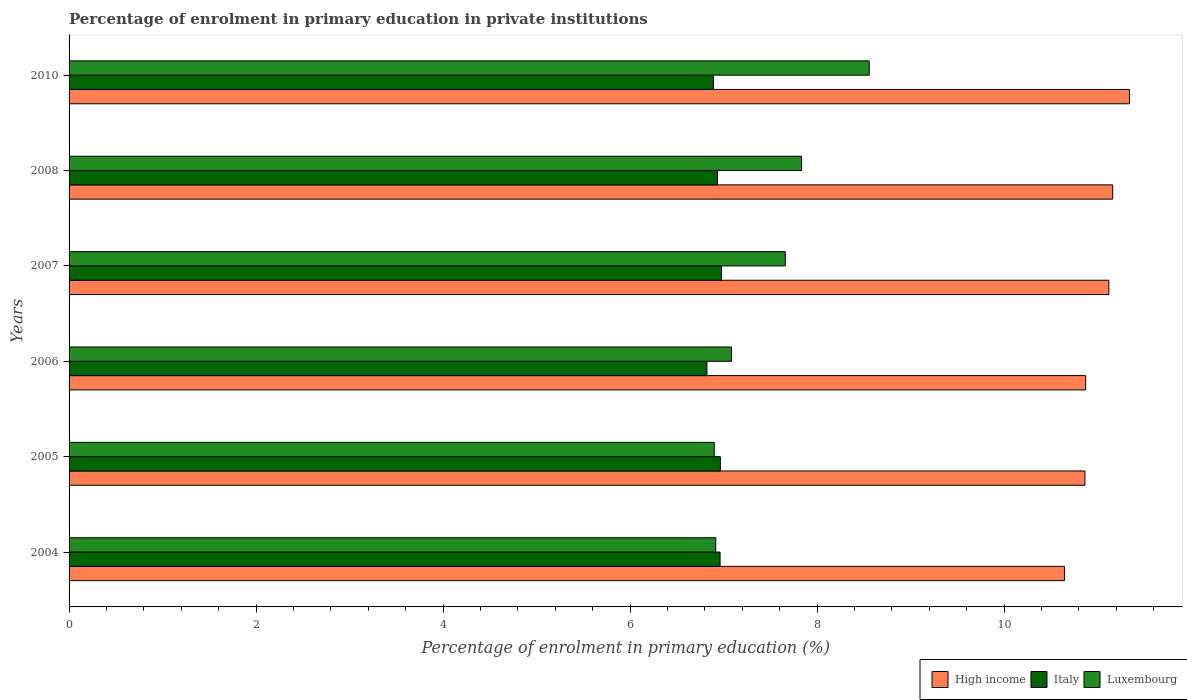Are the number of bars on each tick of the Y-axis equal?
Your answer should be very brief. Yes. How many bars are there on the 5th tick from the top?
Make the answer very short. 3. What is the percentage of enrolment in primary education in Italy in 2005?
Your answer should be compact. 6.97. Across all years, what is the maximum percentage of enrolment in primary education in High income?
Give a very brief answer. 11.34. Across all years, what is the minimum percentage of enrolment in primary education in High income?
Offer a very short reply. 10.64. What is the total percentage of enrolment in primary education in Italy in the graph?
Make the answer very short. 41.55. What is the difference between the percentage of enrolment in primary education in High income in 2005 and that in 2007?
Offer a very short reply. -0.26. What is the difference between the percentage of enrolment in primary education in Luxembourg in 2006 and the percentage of enrolment in primary education in High income in 2007?
Offer a very short reply. -4.04. What is the average percentage of enrolment in primary education in Luxembourg per year?
Provide a succinct answer. 7.49. In the year 2005, what is the difference between the percentage of enrolment in primary education in Luxembourg and percentage of enrolment in primary education in High income?
Provide a short and direct response. -3.96. What is the ratio of the percentage of enrolment in primary education in Italy in 2004 to that in 2006?
Your answer should be very brief. 1.02. Is the difference between the percentage of enrolment in primary education in Luxembourg in 2005 and 2007 greater than the difference between the percentage of enrolment in primary education in High income in 2005 and 2007?
Offer a very short reply. No. What is the difference between the highest and the second highest percentage of enrolment in primary education in Italy?
Offer a terse response. 0.01. What is the difference between the highest and the lowest percentage of enrolment in primary education in Italy?
Offer a terse response. 0.16. What does the 1st bar from the top in 2006 represents?
Your answer should be compact. Luxembourg. What does the 1st bar from the bottom in 2008 represents?
Offer a terse response. High income. Is it the case that in every year, the sum of the percentage of enrolment in primary education in High income and percentage of enrolment in primary education in Italy is greater than the percentage of enrolment in primary education in Luxembourg?
Give a very brief answer. Yes. What is the difference between two consecutive major ticks on the X-axis?
Offer a very short reply. 2. Does the graph contain grids?
Offer a terse response. No. Where does the legend appear in the graph?
Keep it short and to the point. Bottom right. What is the title of the graph?
Ensure brevity in your answer.  Percentage of enrolment in primary education in private institutions. Does "Oman" appear as one of the legend labels in the graph?
Offer a terse response. No. What is the label or title of the X-axis?
Provide a succinct answer. Percentage of enrolment in primary education (%). What is the Percentage of enrolment in primary education (%) of High income in 2004?
Your answer should be very brief. 10.64. What is the Percentage of enrolment in primary education (%) in Italy in 2004?
Make the answer very short. 6.96. What is the Percentage of enrolment in primary education (%) of Luxembourg in 2004?
Keep it short and to the point. 6.92. What is the Percentage of enrolment in primary education (%) in High income in 2005?
Offer a very short reply. 10.86. What is the Percentage of enrolment in primary education (%) in Italy in 2005?
Your answer should be compact. 6.97. What is the Percentage of enrolment in primary education (%) of Luxembourg in 2005?
Offer a terse response. 6.9. What is the Percentage of enrolment in primary education (%) of High income in 2006?
Keep it short and to the point. 10.87. What is the Percentage of enrolment in primary education (%) of Italy in 2006?
Give a very brief answer. 6.82. What is the Percentage of enrolment in primary education (%) of Luxembourg in 2006?
Provide a succinct answer. 7.08. What is the Percentage of enrolment in primary education (%) of High income in 2007?
Your answer should be compact. 11.12. What is the Percentage of enrolment in primary education (%) in Italy in 2007?
Your answer should be compact. 6.98. What is the Percentage of enrolment in primary education (%) in Luxembourg in 2007?
Keep it short and to the point. 7.66. What is the Percentage of enrolment in primary education (%) in High income in 2008?
Make the answer very short. 11.16. What is the Percentage of enrolment in primary education (%) of Italy in 2008?
Your answer should be very brief. 6.93. What is the Percentage of enrolment in primary education (%) of Luxembourg in 2008?
Ensure brevity in your answer.  7.83. What is the Percentage of enrolment in primary education (%) of High income in 2010?
Offer a very short reply. 11.34. What is the Percentage of enrolment in primary education (%) in Italy in 2010?
Your response must be concise. 6.89. What is the Percentage of enrolment in primary education (%) of Luxembourg in 2010?
Give a very brief answer. 8.56. Across all years, what is the maximum Percentage of enrolment in primary education (%) of High income?
Offer a very short reply. 11.34. Across all years, what is the maximum Percentage of enrolment in primary education (%) in Italy?
Give a very brief answer. 6.98. Across all years, what is the maximum Percentage of enrolment in primary education (%) of Luxembourg?
Your answer should be compact. 8.56. Across all years, what is the minimum Percentage of enrolment in primary education (%) of High income?
Give a very brief answer. 10.64. Across all years, what is the minimum Percentage of enrolment in primary education (%) of Italy?
Your answer should be very brief. 6.82. Across all years, what is the minimum Percentage of enrolment in primary education (%) of Luxembourg?
Offer a terse response. 6.9. What is the total Percentage of enrolment in primary education (%) of High income in the graph?
Give a very brief answer. 66. What is the total Percentage of enrolment in primary education (%) of Italy in the graph?
Your answer should be very brief. 41.55. What is the total Percentage of enrolment in primary education (%) in Luxembourg in the graph?
Provide a succinct answer. 44.95. What is the difference between the Percentage of enrolment in primary education (%) in High income in 2004 and that in 2005?
Provide a short and direct response. -0.22. What is the difference between the Percentage of enrolment in primary education (%) of Italy in 2004 and that in 2005?
Make the answer very short. -0. What is the difference between the Percentage of enrolment in primary education (%) in Luxembourg in 2004 and that in 2005?
Give a very brief answer. 0.02. What is the difference between the Percentage of enrolment in primary education (%) in High income in 2004 and that in 2006?
Keep it short and to the point. -0.23. What is the difference between the Percentage of enrolment in primary education (%) in Italy in 2004 and that in 2006?
Offer a very short reply. 0.14. What is the difference between the Percentage of enrolment in primary education (%) in Luxembourg in 2004 and that in 2006?
Offer a terse response. -0.17. What is the difference between the Percentage of enrolment in primary education (%) of High income in 2004 and that in 2007?
Make the answer very short. -0.47. What is the difference between the Percentage of enrolment in primary education (%) in Italy in 2004 and that in 2007?
Your answer should be compact. -0.02. What is the difference between the Percentage of enrolment in primary education (%) of Luxembourg in 2004 and that in 2007?
Give a very brief answer. -0.74. What is the difference between the Percentage of enrolment in primary education (%) of High income in 2004 and that in 2008?
Your answer should be very brief. -0.52. What is the difference between the Percentage of enrolment in primary education (%) of Italy in 2004 and that in 2008?
Offer a very short reply. 0.03. What is the difference between the Percentage of enrolment in primary education (%) in Luxembourg in 2004 and that in 2008?
Ensure brevity in your answer.  -0.92. What is the difference between the Percentage of enrolment in primary education (%) of High income in 2004 and that in 2010?
Keep it short and to the point. -0.7. What is the difference between the Percentage of enrolment in primary education (%) in Italy in 2004 and that in 2010?
Your response must be concise. 0.07. What is the difference between the Percentage of enrolment in primary education (%) of Luxembourg in 2004 and that in 2010?
Give a very brief answer. -1.64. What is the difference between the Percentage of enrolment in primary education (%) in High income in 2005 and that in 2006?
Provide a succinct answer. -0.01. What is the difference between the Percentage of enrolment in primary education (%) in Italy in 2005 and that in 2006?
Provide a short and direct response. 0.14. What is the difference between the Percentage of enrolment in primary education (%) of Luxembourg in 2005 and that in 2006?
Ensure brevity in your answer.  -0.18. What is the difference between the Percentage of enrolment in primary education (%) in High income in 2005 and that in 2007?
Your answer should be compact. -0.26. What is the difference between the Percentage of enrolment in primary education (%) of Italy in 2005 and that in 2007?
Ensure brevity in your answer.  -0.01. What is the difference between the Percentage of enrolment in primary education (%) in Luxembourg in 2005 and that in 2007?
Give a very brief answer. -0.76. What is the difference between the Percentage of enrolment in primary education (%) of High income in 2005 and that in 2008?
Provide a short and direct response. -0.3. What is the difference between the Percentage of enrolment in primary education (%) of Italy in 2005 and that in 2008?
Keep it short and to the point. 0.03. What is the difference between the Percentage of enrolment in primary education (%) in Luxembourg in 2005 and that in 2008?
Keep it short and to the point. -0.93. What is the difference between the Percentage of enrolment in primary education (%) of High income in 2005 and that in 2010?
Provide a short and direct response. -0.48. What is the difference between the Percentage of enrolment in primary education (%) in Italy in 2005 and that in 2010?
Your response must be concise. 0.07. What is the difference between the Percentage of enrolment in primary education (%) in Luxembourg in 2005 and that in 2010?
Ensure brevity in your answer.  -1.66. What is the difference between the Percentage of enrolment in primary education (%) of High income in 2006 and that in 2007?
Provide a succinct answer. -0.25. What is the difference between the Percentage of enrolment in primary education (%) in Italy in 2006 and that in 2007?
Provide a short and direct response. -0.16. What is the difference between the Percentage of enrolment in primary education (%) of Luxembourg in 2006 and that in 2007?
Provide a succinct answer. -0.58. What is the difference between the Percentage of enrolment in primary education (%) of High income in 2006 and that in 2008?
Your response must be concise. -0.29. What is the difference between the Percentage of enrolment in primary education (%) in Italy in 2006 and that in 2008?
Give a very brief answer. -0.11. What is the difference between the Percentage of enrolment in primary education (%) in Luxembourg in 2006 and that in 2008?
Offer a very short reply. -0.75. What is the difference between the Percentage of enrolment in primary education (%) in High income in 2006 and that in 2010?
Your response must be concise. -0.47. What is the difference between the Percentage of enrolment in primary education (%) in Italy in 2006 and that in 2010?
Give a very brief answer. -0.07. What is the difference between the Percentage of enrolment in primary education (%) of Luxembourg in 2006 and that in 2010?
Offer a very short reply. -1.47. What is the difference between the Percentage of enrolment in primary education (%) in High income in 2007 and that in 2008?
Provide a short and direct response. -0.04. What is the difference between the Percentage of enrolment in primary education (%) of Italy in 2007 and that in 2008?
Give a very brief answer. 0.04. What is the difference between the Percentage of enrolment in primary education (%) in Luxembourg in 2007 and that in 2008?
Your response must be concise. -0.17. What is the difference between the Percentage of enrolment in primary education (%) in High income in 2007 and that in 2010?
Offer a terse response. -0.22. What is the difference between the Percentage of enrolment in primary education (%) of Italy in 2007 and that in 2010?
Your answer should be compact. 0.09. What is the difference between the Percentage of enrolment in primary education (%) of Luxembourg in 2007 and that in 2010?
Ensure brevity in your answer.  -0.9. What is the difference between the Percentage of enrolment in primary education (%) in High income in 2008 and that in 2010?
Provide a succinct answer. -0.18. What is the difference between the Percentage of enrolment in primary education (%) of Italy in 2008 and that in 2010?
Keep it short and to the point. 0.04. What is the difference between the Percentage of enrolment in primary education (%) of Luxembourg in 2008 and that in 2010?
Your response must be concise. -0.72. What is the difference between the Percentage of enrolment in primary education (%) of High income in 2004 and the Percentage of enrolment in primary education (%) of Italy in 2005?
Your response must be concise. 3.68. What is the difference between the Percentage of enrolment in primary education (%) in High income in 2004 and the Percentage of enrolment in primary education (%) in Luxembourg in 2005?
Your response must be concise. 3.75. What is the difference between the Percentage of enrolment in primary education (%) of Italy in 2004 and the Percentage of enrolment in primary education (%) of Luxembourg in 2005?
Offer a very short reply. 0.06. What is the difference between the Percentage of enrolment in primary education (%) in High income in 2004 and the Percentage of enrolment in primary education (%) in Italy in 2006?
Offer a very short reply. 3.82. What is the difference between the Percentage of enrolment in primary education (%) in High income in 2004 and the Percentage of enrolment in primary education (%) in Luxembourg in 2006?
Make the answer very short. 3.56. What is the difference between the Percentage of enrolment in primary education (%) of Italy in 2004 and the Percentage of enrolment in primary education (%) of Luxembourg in 2006?
Offer a very short reply. -0.12. What is the difference between the Percentage of enrolment in primary education (%) of High income in 2004 and the Percentage of enrolment in primary education (%) of Italy in 2007?
Offer a very short reply. 3.67. What is the difference between the Percentage of enrolment in primary education (%) in High income in 2004 and the Percentage of enrolment in primary education (%) in Luxembourg in 2007?
Your answer should be compact. 2.99. What is the difference between the Percentage of enrolment in primary education (%) in Italy in 2004 and the Percentage of enrolment in primary education (%) in Luxembourg in 2007?
Your answer should be very brief. -0.7. What is the difference between the Percentage of enrolment in primary education (%) of High income in 2004 and the Percentage of enrolment in primary education (%) of Italy in 2008?
Ensure brevity in your answer.  3.71. What is the difference between the Percentage of enrolment in primary education (%) in High income in 2004 and the Percentage of enrolment in primary education (%) in Luxembourg in 2008?
Offer a very short reply. 2.81. What is the difference between the Percentage of enrolment in primary education (%) of Italy in 2004 and the Percentage of enrolment in primary education (%) of Luxembourg in 2008?
Make the answer very short. -0.87. What is the difference between the Percentage of enrolment in primary education (%) in High income in 2004 and the Percentage of enrolment in primary education (%) in Italy in 2010?
Your response must be concise. 3.75. What is the difference between the Percentage of enrolment in primary education (%) of High income in 2004 and the Percentage of enrolment in primary education (%) of Luxembourg in 2010?
Offer a very short reply. 2.09. What is the difference between the Percentage of enrolment in primary education (%) in Italy in 2004 and the Percentage of enrolment in primary education (%) in Luxembourg in 2010?
Your answer should be very brief. -1.6. What is the difference between the Percentage of enrolment in primary education (%) of High income in 2005 and the Percentage of enrolment in primary education (%) of Italy in 2006?
Offer a terse response. 4.04. What is the difference between the Percentage of enrolment in primary education (%) of High income in 2005 and the Percentage of enrolment in primary education (%) of Luxembourg in 2006?
Your answer should be compact. 3.78. What is the difference between the Percentage of enrolment in primary education (%) of Italy in 2005 and the Percentage of enrolment in primary education (%) of Luxembourg in 2006?
Offer a very short reply. -0.12. What is the difference between the Percentage of enrolment in primary education (%) in High income in 2005 and the Percentage of enrolment in primary education (%) in Italy in 2007?
Offer a terse response. 3.89. What is the difference between the Percentage of enrolment in primary education (%) in High income in 2005 and the Percentage of enrolment in primary education (%) in Luxembourg in 2007?
Offer a very short reply. 3.2. What is the difference between the Percentage of enrolment in primary education (%) in Italy in 2005 and the Percentage of enrolment in primary education (%) in Luxembourg in 2007?
Your answer should be very brief. -0.69. What is the difference between the Percentage of enrolment in primary education (%) of High income in 2005 and the Percentage of enrolment in primary education (%) of Italy in 2008?
Provide a short and direct response. 3.93. What is the difference between the Percentage of enrolment in primary education (%) of High income in 2005 and the Percentage of enrolment in primary education (%) of Luxembourg in 2008?
Provide a succinct answer. 3.03. What is the difference between the Percentage of enrolment in primary education (%) of Italy in 2005 and the Percentage of enrolment in primary education (%) of Luxembourg in 2008?
Offer a terse response. -0.87. What is the difference between the Percentage of enrolment in primary education (%) in High income in 2005 and the Percentage of enrolment in primary education (%) in Italy in 2010?
Make the answer very short. 3.97. What is the difference between the Percentage of enrolment in primary education (%) of High income in 2005 and the Percentage of enrolment in primary education (%) of Luxembourg in 2010?
Offer a terse response. 2.31. What is the difference between the Percentage of enrolment in primary education (%) in Italy in 2005 and the Percentage of enrolment in primary education (%) in Luxembourg in 2010?
Offer a very short reply. -1.59. What is the difference between the Percentage of enrolment in primary education (%) of High income in 2006 and the Percentage of enrolment in primary education (%) of Italy in 2007?
Your answer should be compact. 3.89. What is the difference between the Percentage of enrolment in primary education (%) in High income in 2006 and the Percentage of enrolment in primary education (%) in Luxembourg in 2007?
Make the answer very short. 3.21. What is the difference between the Percentage of enrolment in primary education (%) of Italy in 2006 and the Percentage of enrolment in primary education (%) of Luxembourg in 2007?
Offer a terse response. -0.84. What is the difference between the Percentage of enrolment in primary education (%) of High income in 2006 and the Percentage of enrolment in primary education (%) of Italy in 2008?
Your response must be concise. 3.94. What is the difference between the Percentage of enrolment in primary education (%) in High income in 2006 and the Percentage of enrolment in primary education (%) in Luxembourg in 2008?
Your answer should be compact. 3.04. What is the difference between the Percentage of enrolment in primary education (%) of Italy in 2006 and the Percentage of enrolment in primary education (%) of Luxembourg in 2008?
Your answer should be compact. -1.01. What is the difference between the Percentage of enrolment in primary education (%) of High income in 2006 and the Percentage of enrolment in primary education (%) of Italy in 2010?
Offer a very short reply. 3.98. What is the difference between the Percentage of enrolment in primary education (%) of High income in 2006 and the Percentage of enrolment in primary education (%) of Luxembourg in 2010?
Provide a succinct answer. 2.31. What is the difference between the Percentage of enrolment in primary education (%) of Italy in 2006 and the Percentage of enrolment in primary education (%) of Luxembourg in 2010?
Offer a terse response. -1.74. What is the difference between the Percentage of enrolment in primary education (%) in High income in 2007 and the Percentage of enrolment in primary education (%) in Italy in 2008?
Offer a very short reply. 4.19. What is the difference between the Percentage of enrolment in primary education (%) of High income in 2007 and the Percentage of enrolment in primary education (%) of Luxembourg in 2008?
Your answer should be compact. 3.29. What is the difference between the Percentage of enrolment in primary education (%) in Italy in 2007 and the Percentage of enrolment in primary education (%) in Luxembourg in 2008?
Give a very brief answer. -0.86. What is the difference between the Percentage of enrolment in primary education (%) of High income in 2007 and the Percentage of enrolment in primary education (%) of Italy in 2010?
Your answer should be very brief. 4.23. What is the difference between the Percentage of enrolment in primary education (%) in High income in 2007 and the Percentage of enrolment in primary education (%) in Luxembourg in 2010?
Offer a terse response. 2.56. What is the difference between the Percentage of enrolment in primary education (%) of Italy in 2007 and the Percentage of enrolment in primary education (%) of Luxembourg in 2010?
Give a very brief answer. -1.58. What is the difference between the Percentage of enrolment in primary education (%) in High income in 2008 and the Percentage of enrolment in primary education (%) in Italy in 2010?
Make the answer very short. 4.27. What is the difference between the Percentage of enrolment in primary education (%) of High income in 2008 and the Percentage of enrolment in primary education (%) of Luxembourg in 2010?
Your answer should be very brief. 2.6. What is the difference between the Percentage of enrolment in primary education (%) in Italy in 2008 and the Percentage of enrolment in primary education (%) in Luxembourg in 2010?
Your answer should be very brief. -1.62. What is the average Percentage of enrolment in primary education (%) of High income per year?
Provide a short and direct response. 11. What is the average Percentage of enrolment in primary education (%) of Italy per year?
Your answer should be very brief. 6.93. What is the average Percentage of enrolment in primary education (%) in Luxembourg per year?
Your answer should be compact. 7.49. In the year 2004, what is the difference between the Percentage of enrolment in primary education (%) of High income and Percentage of enrolment in primary education (%) of Italy?
Keep it short and to the point. 3.68. In the year 2004, what is the difference between the Percentage of enrolment in primary education (%) of High income and Percentage of enrolment in primary education (%) of Luxembourg?
Provide a short and direct response. 3.73. In the year 2004, what is the difference between the Percentage of enrolment in primary education (%) in Italy and Percentage of enrolment in primary education (%) in Luxembourg?
Provide a succinct answer. 0.05. In the year 2005, what is the difference between the Percentage of enrolment in primary education (%) in High income and Percentage of enrolment in primary education (%) in Italy?
Provide a succinct answer. 3.9. In the year 2005, what is the difference between the Percentage of enrolment in primary education (%) of High income and Percentage of enrolment in primary education (%) of Luxembourg?
Your answer should be very brief. 3.96. In the year 2005, what is the difference between the Percentage of enrolment in primary education (%) in Italy and Percentage of enrolment in primary education (%) in Luxembourg?
Offer a very short reply. 0.07. In the year 2006, what is the difference between the Percentage of enrolment in primary education (%) of High income and Percentage of enrolment in primary education (%) of Italy?
Offer a very short reply. 4.05. In the year 2006, what is the difference between the Percentage of enrolment in primary education (%) of High income and Percentage of enrolment in primary education (%) of Luxembourg?
Give a very brief answer. 3.79. In the year 2006, what is the difference between the Percentage of enrolment in primary education (%) of Italy and Percentage of enrolment in primary education (%) of Luxembourg?
Offer a very short reply. -0.26. In the year 2007, what is the difference between the Percentage of enrolment in primary education (%) of High income and Percentage of enrolment in primary education (%) of Italy?
Make the answer very short. 4.14. In the year 2007, what is the difference between the Percentage of enrolment in primary education (%) in High income and Percentage of enrolment in primary education (%) in Luxembourg?
Provide a succinct answer. 3.46. In the year 2007, what is the difference between the Percentage of enrolment in primary education (%) in Italy and Percentage of enrolment in primary education (%) in Luxembourg?
Keep it short and to the point. -0.68. In the year 2008, what is the difference between the Percentage of enrolment in primary education (%) of High income and Percentage of enrolment in primary education (%) of Italy?
Give a very brief answer. 4.23. In the year 2008, what is the difference between the Percentage of enrolment in primary education (%) in High income and Percentage of enrolment in primary education (%) in Luxembourg?
Keep it short and to the point. 3.33. In the year 2008, what is the difference between the Percentage of enrolment in primary education (%) in Italy and Percentage of enrolment in primary education (%) in Luxembourg?
Your answer should be very brief. -0.9. In the year 2010, what is the difference between the Percentage of enrolment in primary education (%) in High income and Percentage of enrolment in primary education (%) in Italy?
Your response must be concise. 4.45. In the year 2010, what is the difference between the Percentage of enrolment in primary education (%) of High income and Percentage of enrolment in primary education (%) of Luxembourg?
Provide a short and direct response. 2.78. In the year 2010, what is the difference between the Percentage of enrolment in primary education (%) of Italy and Percentage of enrolment in primary education (%) of Luxembourg?
Your answer should be very brief. -1.67. What is the ratio of the Percentage of enrolment in primary education (%) in High income in 2004 to that in 2005?
Offer a very short reply. 0.98. What is the ratio of the Percentage of enrolment in primary education (%) in Luxembourg in 2004 to that in 2005?
Offer a very short reply. 1. What is the ratio of the Percentage of enrolment in primary education (%) in High income in 2004 to that in 2006?
Provide a short and direct response. 0.98. What is the ratio of the Percentage of enrolment in primary education (%) in Italy in 2004 to that in 2006?
Ensure brevity in your answer.  1.02. What is the ratio of the Percentage of enrolment in primary education (%) of Luxembourg in 2004 to that in 2006?
Make the answer very short. 0.98. What is the ratio of the Percentage of enrolment in primary education (%) in High income in 2004 to that in 2007?
Keep it short and to the point. 0.96. What is the ratio of the Percentage of enrolment in primary education (%) in Luxembourg in 2004 to that in 2007?
Your answer should be very brief. 0.9. What is the ratio of the Percentage of enrolment in primary education (%) of High income in 2004 to that in 2008?
Make the answer very short. 0.95. What is the ratio of the Percentage of enrolment in primary education (%) of Luxembourg in 2004 to that in 2008?
Give a very brief answer. 0.88. What is the ratio of the Percentage of enrolment in primary education (%) in High income in 2004 to that in 2010?
Make the answer very short. 0.94. What is the ratio of the Percentage of enrolment in primary education (%) of Italy in 2004 to that in 2010?
Keep it short and to the point. 1.01. What is the ratio of the Percentage of enrolment in primary education (%) in Luxembourg in 2004 to that in 2010?
Give a very brief answer. 0.81. What is the ratio of the Percentage of enrolment in primary education (%) of Italy in 2005 to that in 2006?
Give a very brief answer. 1.02. What is the ratio of the Percentage of enrolment in primary education (%) of Italy in 2005 to that in 2007?
Provide a succinct answer. 1. What is the ratio of the Percentage of enrolment in primary education (%) in Luxembourg in 2005 to that in 2007?
Provide a short and direct response. 0.9. What is the ratio of the Percentage of enrolment in primary education (%) in High income in 2005 to that in 2008?
Make the answer very short. 0.97. What is the ratio of the Percentage of enrolment in primary education (%) in Italy in 2005 to that in 2008?
Offer a very short reply. 1. What is the ratio of the Percentage of enrolment in primary education (%) of Luxembourg in 2005 to that in 2008?
Keep it short and to the point. 0.88. What is the ratio of the Percentage of enrolment in primary education (%) in High income in 2005 to that in 2010?
Your answer should be compact. 0.96. What is the ratio of the Percentage of enrolment in primary education (%) in Italy in 2005 to that in 2010?
Provide a succinct answer. 1.01. What is the ratio of the Percentage of enrolment in primary education (%) in Luxembourg in 2005 to that in 2010?
Offer a terse response. 0.81. What is the ratio of the Percentage of enrolment in primary education (%) of High income in 2006 to that in 2007?
Ensure brevity in your answer.  0.98. What is the ratio of the Percentage of enrolment in primary education (%) of Italy in 2006 to that in 2007?
Your answer should be compact. 0.98. What is the ratio of the Percentage of enrolment in primary education (%) in Luxembourg in 2006 to that in 2007?
Your answer should be compact. 0.92. What is the ratio of the Percentage of enrolment in primary education (%) in High income in 2006 to that in 2008?
Offer a terse response. 0.97. What is the ratio of the Percentage of enrolment in primary education (%) in Italy in 2006 to that in 2008?
Ensure brevity in your answer.  0.98. What is the ratio of the Percentage of enrolment in primary education (%) in Luxembourg in 2006 to that in 2008?
Give a very brief answer. 0.9. What is the ratio of the Percentage of enrolment in primary education (%) of High income in 2006 to that in 2010?
Ensure brevity in your answer.  0.96. What is the ratio of the Percentage of enrolment in primary education (%) in Luxembourg in 2006 to that in 2010?
Keep it short and to the point. 0.83. What is the ratio of the Percentage of enrolment in primary education (%) in Luxembourg in 2007 to that in 2008?
Give a very brief answer. 0.98. What is the ratio of the Percentage of enrolment in primary education (%) in High income in 2007 to that in 2010?
Ensure brevity in your answer.  0.98. What is the ratio of the Percentage of enrolment in primary education (%) in Italy in 2007 to that in 2010?
Offer a terse response. 1.01. What is the ratio of the Percentage of enrolment in primary education (%) in Luxembourg in 2007 to that in 2010?
Provide a succinct answer. 0.9. What is the ratio of the Percentage of enrolment in primary education (%) of High income in 2008 to that in 2010?
Give a very brief answer. 0.98. What is the ratio of the Percentage of enrolment in primary education (%) of Italy in 2008 to that in 2010?
Your response must be concise. 1.01. What is the ratio of the Percentage of enrolment in primary education (%) in Luxembourg in 2008 to that in 2010?
Offer a very short reply. 0.92. What is the difference between the highest and the second highest Percentage of enrolment in primary education (%) of High income?
Provide a succinct answer. 0.18. What is the difference between the highest and the second highest Percentage of enrolment in primary education (%) in Italy?
Make the answer very short. 0.01. What is the difference between the highest and the second highest Percentage of enrolment in primary education (%) of Luxembourg?
Make the answer very short. 0.72. What is the difference between the highest and the lowest Percentage of enrolment in primary education (%) in High income?
Offer a very short reply. 0.7. What is the difference between the highest and the lowest Percentage of enrolment in primary education (%) of Italy?
Your answer should be very brief. 0.16. What is the difference between the highest and the lowest Percentage of enrolment in primary education (%) of Luxembourg?
Provide a succinct answer. 1.66. 